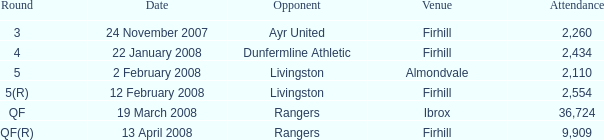Who was the opponent at the qf(r) round? Rangers. 